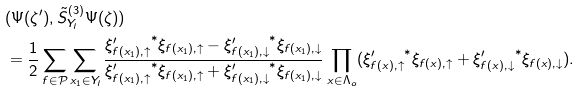<formula> <loc_0><loc_0><loc_500><loc_500>& ( \Psi ( \zeta ^ { \prime } ) , \tilde { S } ^ { ( 3 ) } _ { Y _ { l } } \Psi ( \zeta ) ) \\ & = \frac { 1 } { 2 } \sum _ { f \in \mathcal { P } } \sum _ { x _ { 1 } \in Y _ { l } } \frac { { \xi ^ { \prime } _ { f ( x _ { 1 } ) , \uparrow } } ^ { * } \xi _ { f ( x _ { 1 } ) , \uparrow } - { \xi ^ { \prime } _ { f ( x _ { 1 } ) , \downarrow } } ^ { * } \xi _ { f ( x _ { 1 } ) , \downarrow } } { { \xi ^ { \prime } _ { f ( x _ { 1 } ) , \uparrow } } ^ { * } \xi _ { f ( x _ { 1 } ) , \uparrow } + { \xi ^ { \prime } _ { f ( x _ { 1 } ) , \downarrow } } ^ { * } \xi _ { f ( x _ { 1 } ) , \downarrow } } \prod _ { x \in \Lambda _ { o } } ( { \xi ^ { \prime } _ { f ( x ) , \uparrow } } ^ { * } \xi _ { f ( x ) , \uparrow } + { \xi ^ { \prime } _ { f ( x ) , \downarrow } } ^ { * } \xi _ { f ( x ) , \downarrow } ) .</formula> 